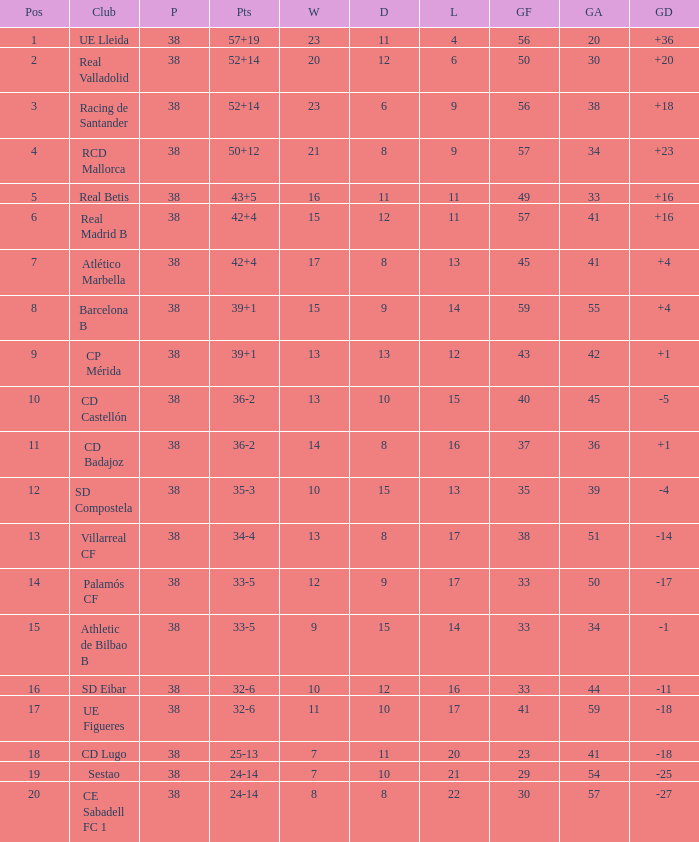Would you mind parsing the complete table? {'header': ['Pos', 'Club', 'P', 'Pts', 'W', 'D', 'L', 'GF', 'GA', 'GD'], 'rows': [['1', 'UE Lleida', '38', '57+19', '23', '11', '4', '56', '20', '+36'], ['2', 'Real Valladolid', '38', '52+14', '20', '12', '6', '50', '30', '+20'], ['3', 'Racing de Santander', '38', '52+14', '23', '6', '9', '56', '38', '+18'], ['4', 'RCD Mallorca', '38', '50+12', '21', '8', '9', '57', '34', '+23'], ['5', 'Real Betis', '38', '43+5', '16', '11', '11', '49', '33', '+16'], ['6', 'Real Madrid B', '38', '42+4', '15', '12', '11', '57', '41', '+16'], ['7', 'Atlético Marbella', '38', '42+4', '17', '8', '13', '45', '41', '+4'], ['8', 'Barcelona B', '38', '39+1', '15', '9', '14', '59', '55', '+4'], ['9', 'CP Mérida', '38', '39+1', '13', '13', '12', '43', '42', '+1'], ['10', 'CD Castellón', '38', '36-2', '13', '10', '15', '40', '45', '-5'], ['11', 'CD Badajoz', '38', '36-2', '14', '8', '16', '37', '36', '+1'], ['12', 'SD Compostela', '38', '35-3', '10', '15', '13', '35', '39', '-4'], ['13', 'Villarreal CF', '38', '34-4', '13', '8', '17', '38', '51', '-14'], ['14', 'Palamós CF', '38', '33-5', '12', '9', '17', '33', '50', '-17'], ['15', 'Athletic de Bilbao B', '38', '33-5', '9', '15', '14', '33', '34', '-1'], ['16', 'SD Eibar', '38', '32-6', '10', '12', '16', '33', '44', '-11'], ['17', 'UE Figueres', '38', '32-6', '11', '10', '17', '41', '59', '-18'], ['18', 'CD Lugo', '38', '25-13', '7', '11', '20', '23', '41', '-18'], ['19', 'Sestao', '38', '24-14', '7', '10', '21', '29', '54', '-25'], ['20', 'CE Sabadell FC 1', '38', '24-14', '8', '8', '22', '30', '57', '-27']]} What is the highest position with less than 17 losses, more than 57 goals, and a goal difference less than 4? None. 